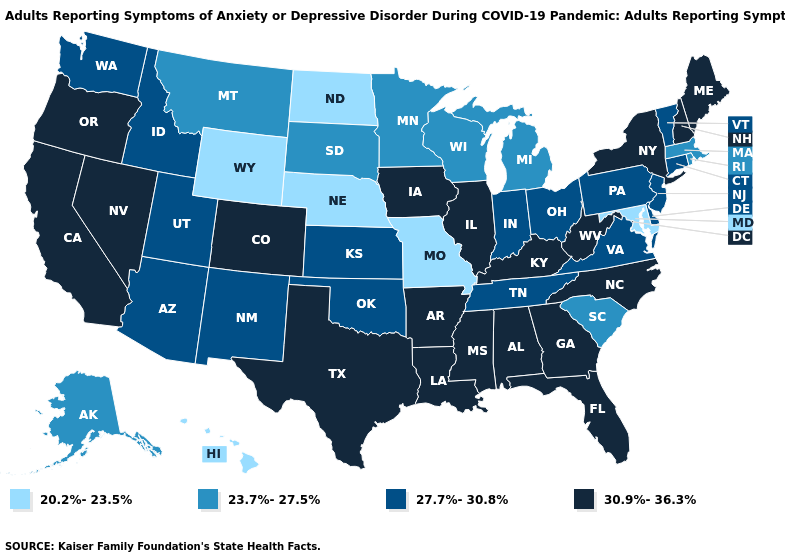What is the value of South Carolina?
Answer briefly. 23.7%-27.5%. What is the highest value in states that border Iowa?
Be succinct. 30.9%-36.3%. Does Idaho have a lower value than North Dakota?
Concise answer only. No. Name the states that have a value in the range 23.7%-27.5%?
Write a very short answer. Alaska, Massachusetts, Michigan, Minnesota, Montana, Rhode Island, South Carolina, South Dakota, Wisconsin. Name the states that have a value in the range 20.2%-23.5%?
Keep it brief. Hawaii, Maryland, Missouri, Nebraska, North Dakota, Wyoming. What is the value of New York?
Quick response, please. 30.9%-36.3%. What is the value of Pennsylvania?
Give a very brief answer. 27.7%-30.8%. Name the states that have a value in the range 20.2%-23.5%?
Write a very short answer. Hawaii, Maryland, Missouri, Nebraska, North Dakota, Wyoming. What is the highest value in the USA?
Give a very brief answer. 30.9%-36.3%. What is the lowest value in the USA?
Write a very short answer. 20.2%-23.5%. What is the lowest value in states that border South Dakota?
Short answer required. 20.2%-23.5%. Which states have the lowest value in the USA?
Quick response, please. Hawaii, Maryland, Missouri, Nebraska, North Dakota, Wyoming. Name the states that have a value in the range 30.9%-36.3%?
Be succinct. Alabama, Arkansas, California, Colorado, Florida, Georgia, Illinois, Iowa, Kentucky, Louisiana, Maine, Mississippi, Nevada, New Hampshire, New York, North Carolina, Oregon, Texas, West Virginia. Name the states that have a value in the range 30.9%-36.3%?
Short answer required. Alabama, Arkansas, California, Colorado, Florida, Georgia, Illinois, Iowa, Kentucky, Louisiana, Maine, Mississippi, Nevada, New Hampshire, New York, North Carolina, Oregon, Texas, West Virginia. 